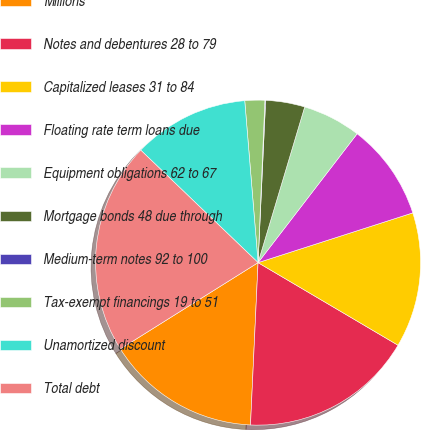Convert chart to OTSL. <chart><loc_0><loc_0><loc_500><loc_500><pie_chart><fcel>Millions<fcel>Notes and debentures 28 to 79<fcel>Capitalized leases 31 to 84<fcel>Floating rate term loans due<fcel>Equipment obligations 62 to 67<fcel>Mortgage bonds 48 due through<fcel>Medium-term notes 92 to 100<fcel>Tax-exempt financings 19 to 51<fcel>Unamortized discount<fcel>Total debt<nl><fcel>15.35%<fcel>17.26%<fcel>13.44%<fcel>9.62%<fcel>5.8%<fcel>3.89%<fcel>0.07%<fcel>1.98%<fcel>11.53%<fcel>21.08%<nl></chart> 